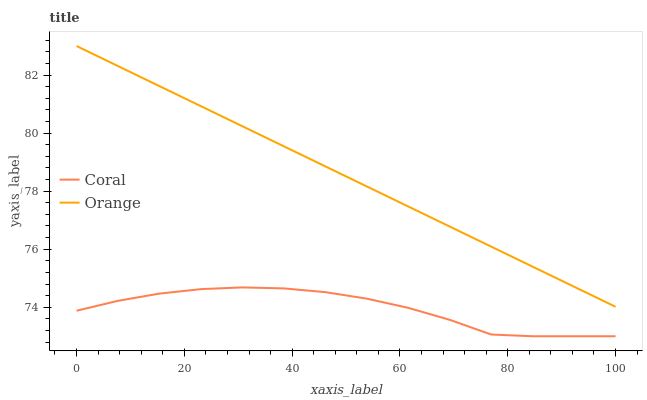Does Coral have the minimum area under the curve?
Answer yes or no. Yes. Does Orange have the maximum area under the curve?
Answer yes or no. Yes. Does Coral have the maximum area under the curve?
Answer yes or no. No. Is Orange the smoothest?
Answer yes or no. Yes. Is Coral the roughest?
Answer yes or no. Yes. Is Coral the smoothest?
Answer yes or no. No. Does Coral have the lowest value?
Answer yes or no. Yes. Does Orange have the highest value?
Answer yes or no. Yes. Does Coral have the highest value?
Answer yes or no. No. Is Coral less than Orange?
Answer yes or no. Yes. Is Orange greater than Coral?
Answer yes or no. Yes. Does Coral intersect Orange?
Answer yes or no. No. 